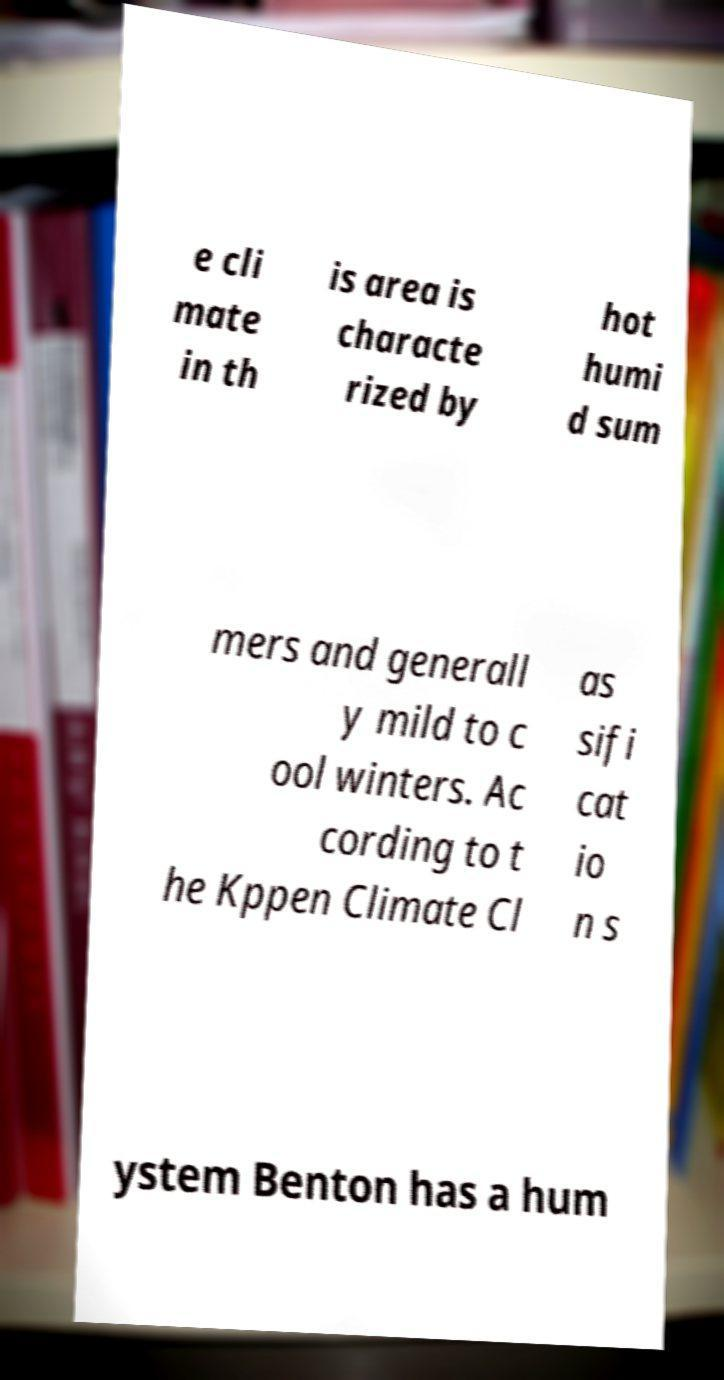Please read and relay the text visible in this image. What does it say? e cli mate in th is area is characte rized by hot humi d sum mers and generall y mild to c ool winters. Ac cording to t he Kppen Climate Cl as sifi cat io n s ystem Benton has a hum 